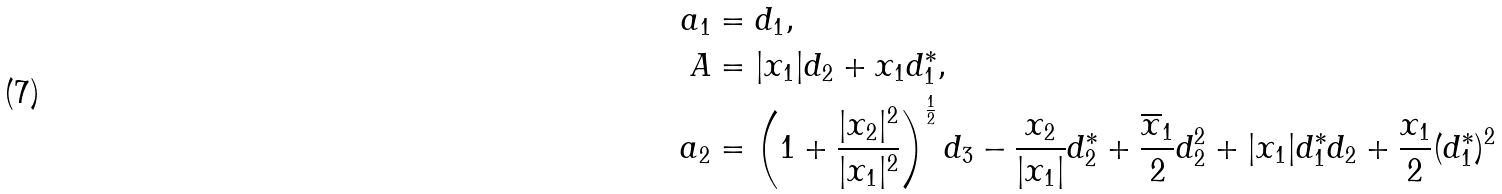Convert formula to latex. <formula><loc_0><loc_0><loc_500><loc_500>a _ { 1 } & = d _ { 1 } , \\ A & = | x _ { 1 } | d _ { 2 } + x _ { 1 } d _ { 1 } ^ { * } , \\ a _ { 2 } & = \left ( 1 + \frac { | x _ { 2 } | ^ { 2 } } { | x _ { 1 } | ^ { 2 } } \right ) ^ { \frac { 1 } { 2 } } d _ { 3 } - \frac { x _ { 2 } } { | x _ { 1 } | } d _ { 2 } ^ { * } + \frac { \overline { x } _ { 1 } } { 2 } d _ { 2 } ^ { 2 } + | x _ { 1 } | d _ { 1 } ^ { * } d _ { 2 } + \frac { x _ { 1 } } { 2 } ( d _ { 1 } ^ { * } ) ^ { 2 }</formula> 